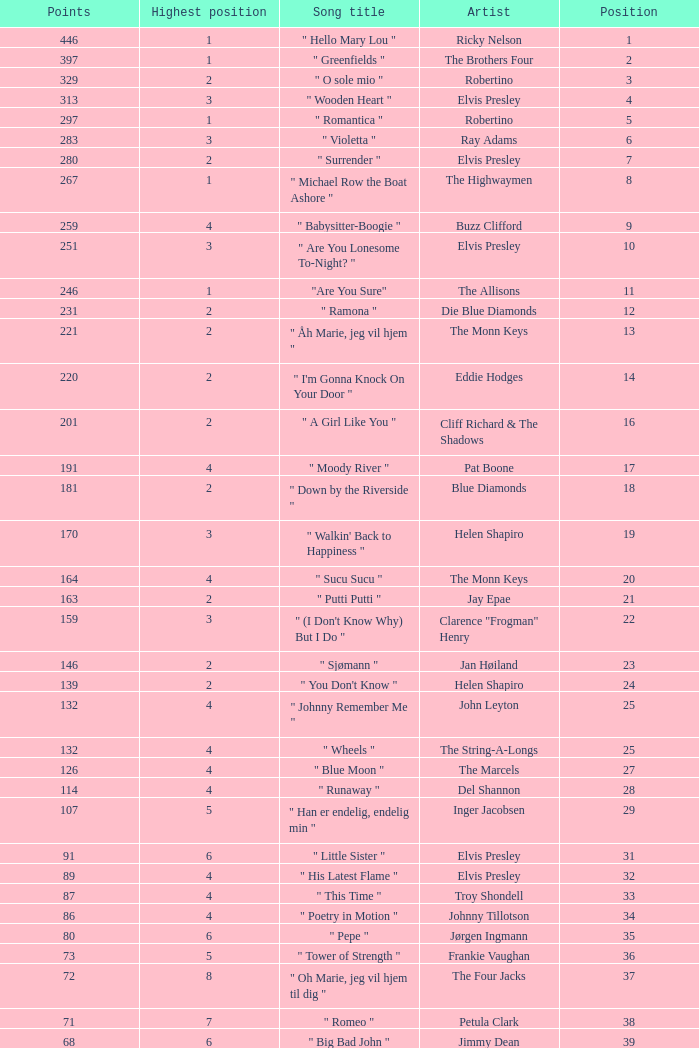What is highest place reached by artist Ray Adams? 6.0. 